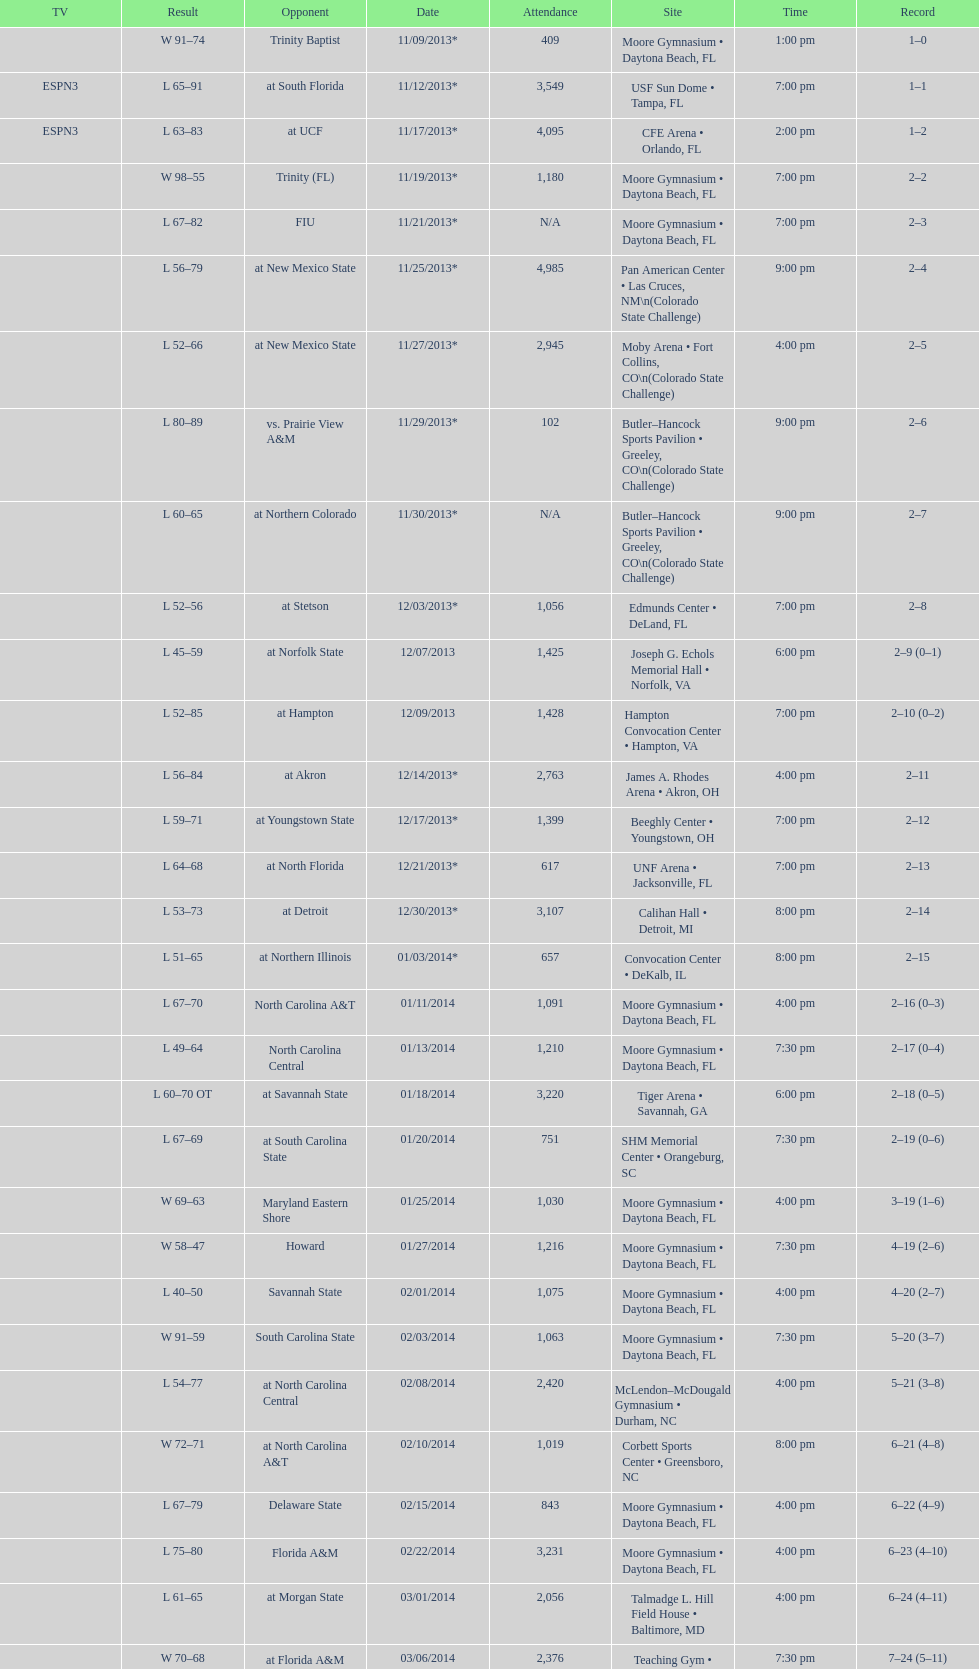How many teams had at most an attendance of 1,000? 6. 